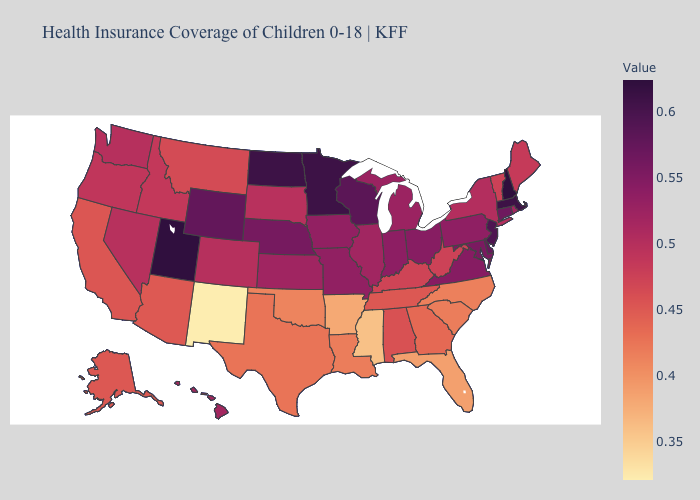Does the map have missing data?
Quick response, please. No. Among the states that border New Hampshire , does Maine have the lowest value?
Concise answer only. No. Which states have the lowest value in the Northeast?
Be succinct. Vermont. Which states have the lowest value in the USA?
Quick response, please. New Mexico. 